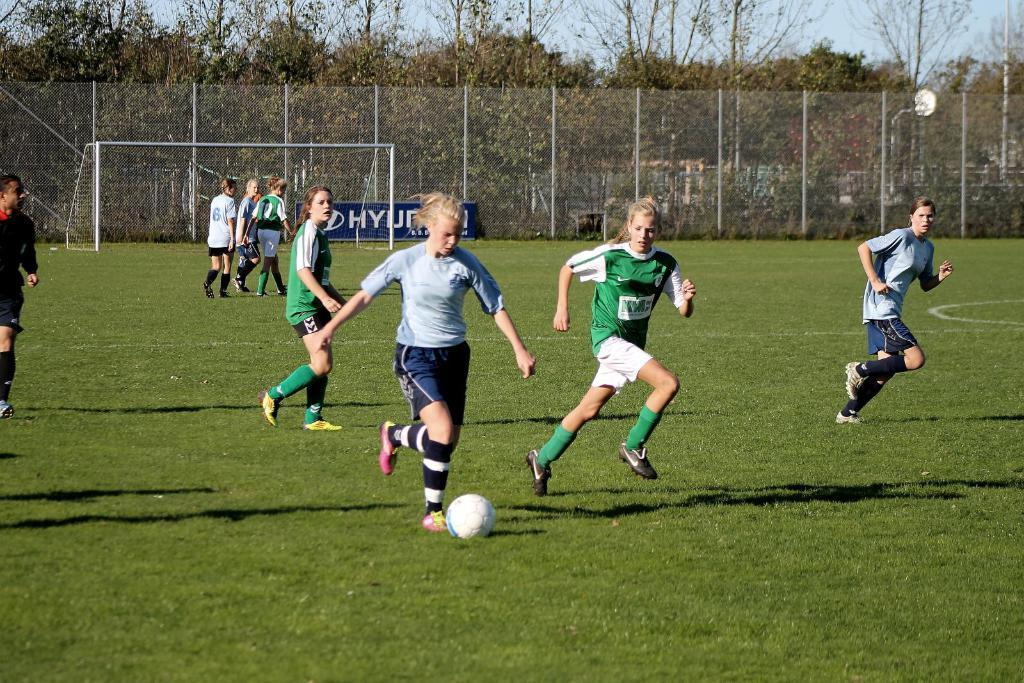What is the primary feature of the land in the image? The land is covered with grass. What are the three people doing in the image? The three people are running. Can you identify the gender of one of the running people? Yes, a woman is among the running people. What is in front of the woman while she is running? There is a ball in front of the woman. What can be seen in the background of the image? There are people, a mesh, trees, and plants visible in the background of the image. What type of town can be seen in the background of the image? There is no town visible in the background of the image; it features a mesh, trees, and plants. What is the woman doing with her head in the image? There is no specific action involving the woman's head mentioned in the image; she is simply running with the other people. 